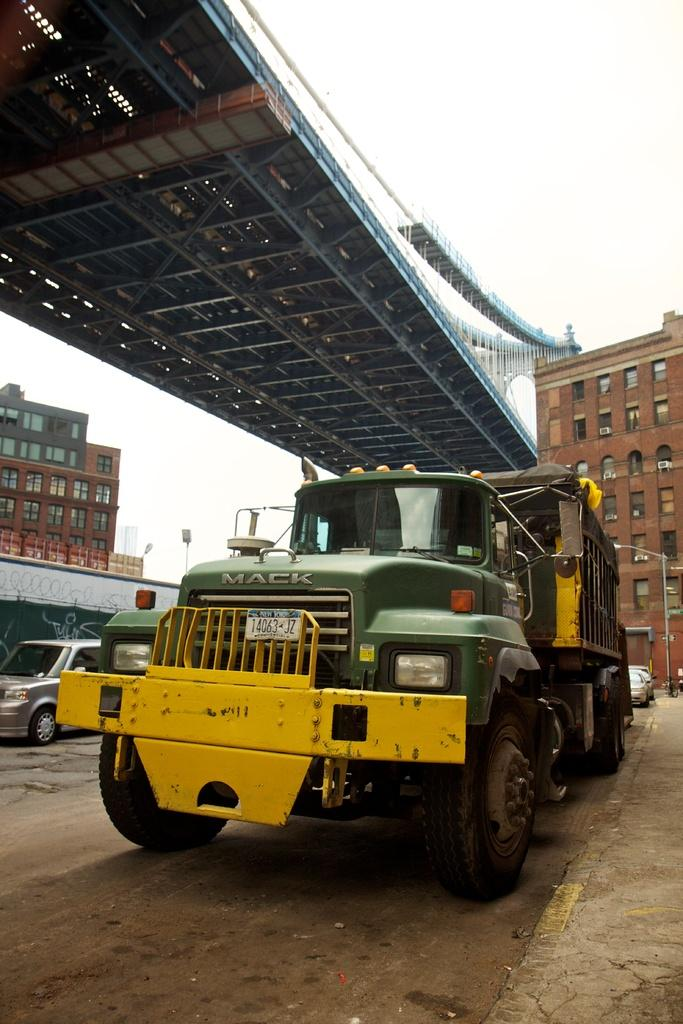<image>
Present a compact description of the photo's key features. A green and yellow Mack truck under a bridge. 